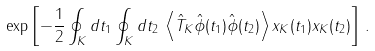<formula> <loc_0><loc_0><loc_500><loc_500>\exp \left [ - \frac { 1 } { 2 } \oint _ { K } d t _ { 1 } \oint _ { K } d t _ { 2 } \, \left \langle \hat { T } _ { K } \hat { \phi } ( t _ { 1 } ) \hat { \phi } ( t _ { 2 } ) \right \rangle x _ { K } ( t _ { 1 } ) x _ { K } ( t _ { 2 } ) \right ] \, .</formula> 